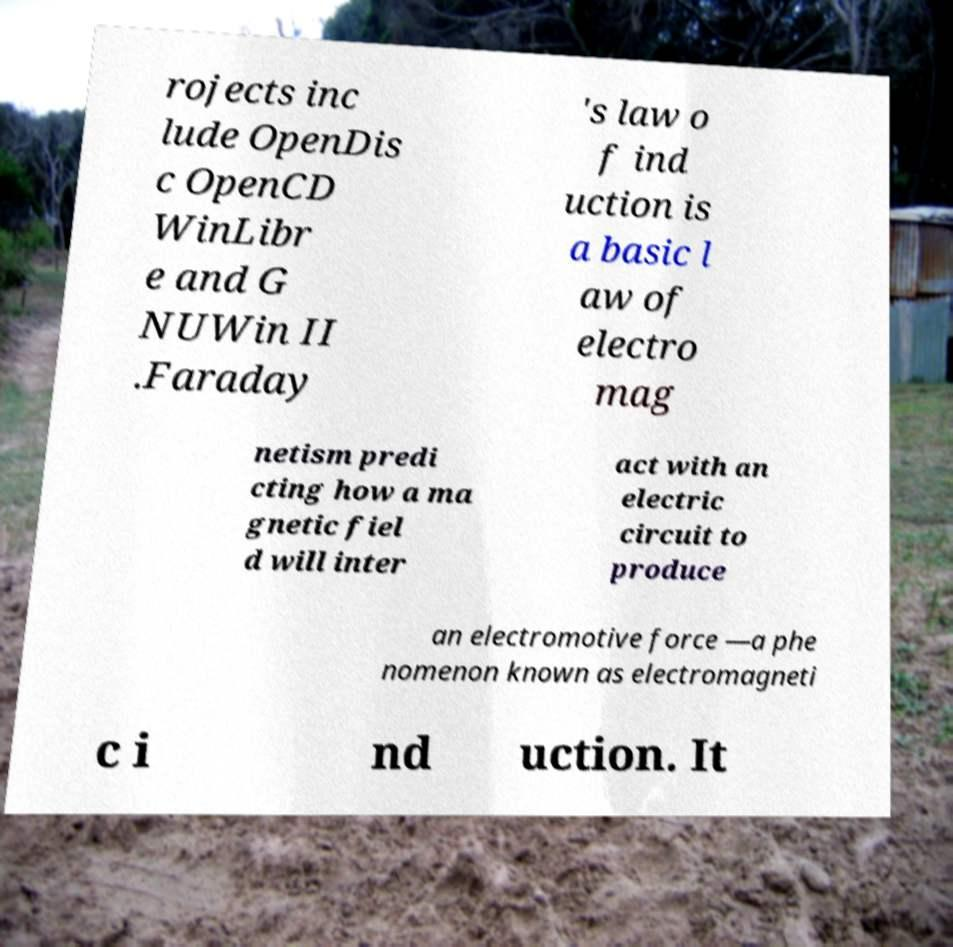For documentation purposes, I need the text within this image transcribed. Could you provide that? rojects inc lude OpenDis c OpenCD WinLibr e and G NUWin II .Faraday 's law o f ind uction is a basic l aw of electro mag netism predi cting how a ma gnetic fiel d will inter act with an electric circuit to produce an electromotive force —a phe nomenon known as electromagneti c i nd uction. It 